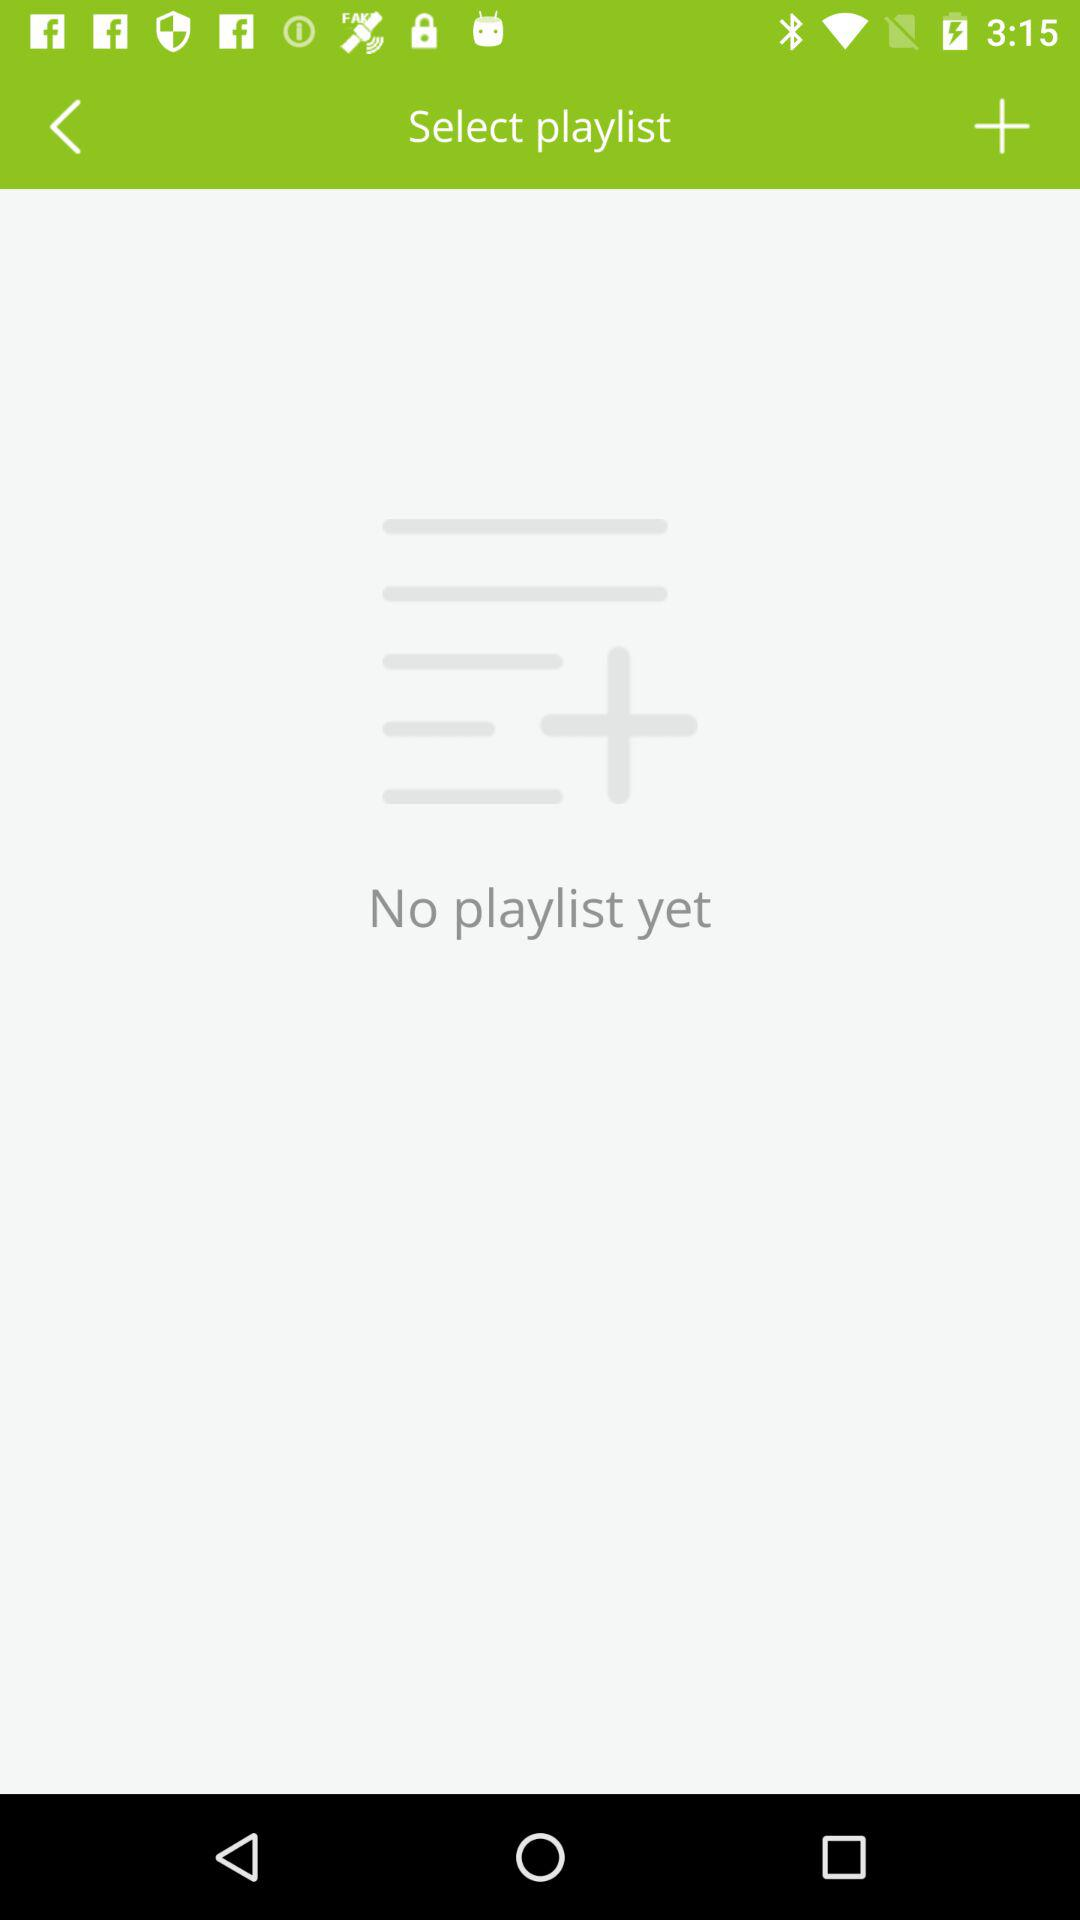Is there a playlist? There is no playlist. 